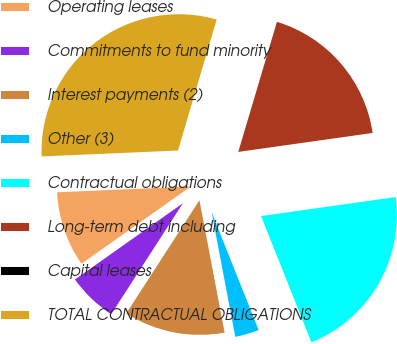<chart> <loc_0><loc_0><loc_500><loc_500><pie_chart><fcel>Operating leases<fcel>Commitments to fund minority<fcel>Interest payments (2)<fcel>Other (3)<fcel>Contractual obligations<fcel>Long-term debt including<fcel>Capital leases<fcel>TOTAL CONTRACTUAL OBLIGATIONS<nl><fcel>9.1%<fcel>6.08%<fcel>12.12%<fcel>3.05%<fcel>21.19%<fcel>18.17%<fcel>0.03%<fcel>30.26%<nl></chart> 